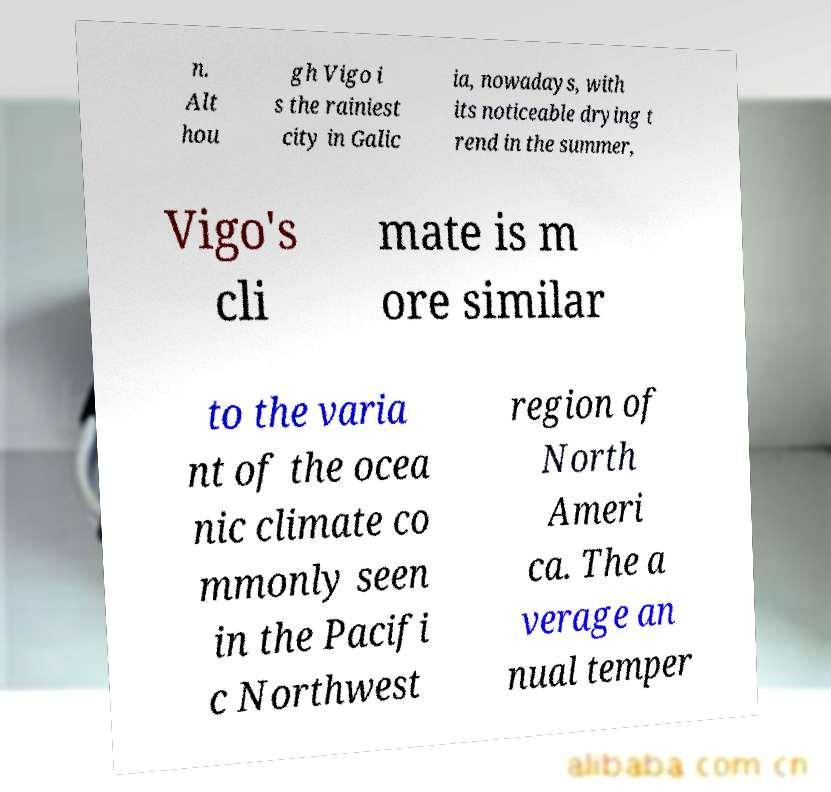Could you assist in decoding the text presented in this image and type it out clearly? n. Alt hou gh Vigo i s the rainiest city in Galic ia, nowadays, with its noticeable drying t rend in the summer, Vigo's cli mate is m ore similar to the varia nt of the ocea nic climate co mmonly seen in the Pacifi c Northwest region of North Ameri ca. The a verage an nual temper 